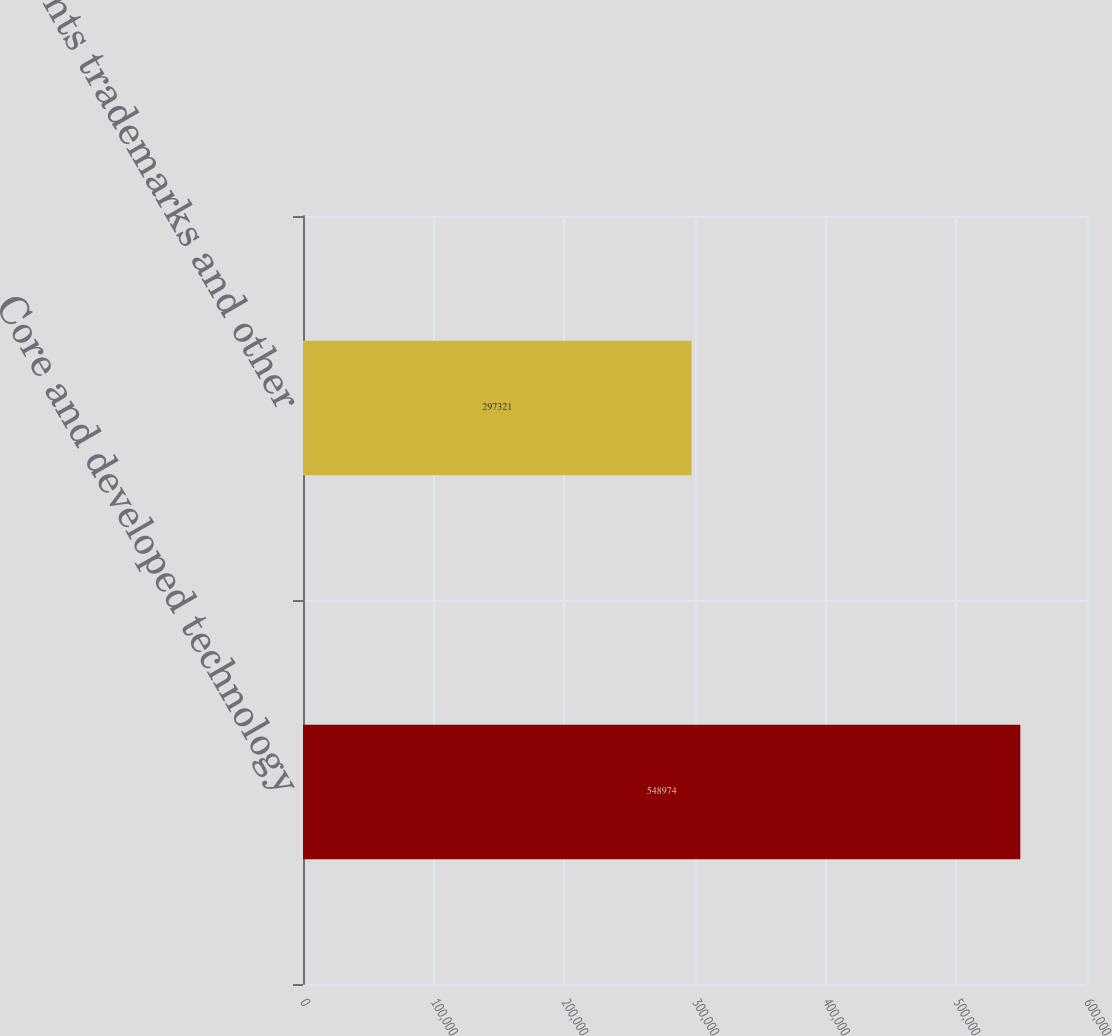Convert chart to OTSL. <chart><loc_0><loc_0><loc_500><loc_500><bar_chart><fcel>Core and developed technology<fcel>Patents trademarks and other<nl><fcel>548974<fcel>297321<nl></chart> 